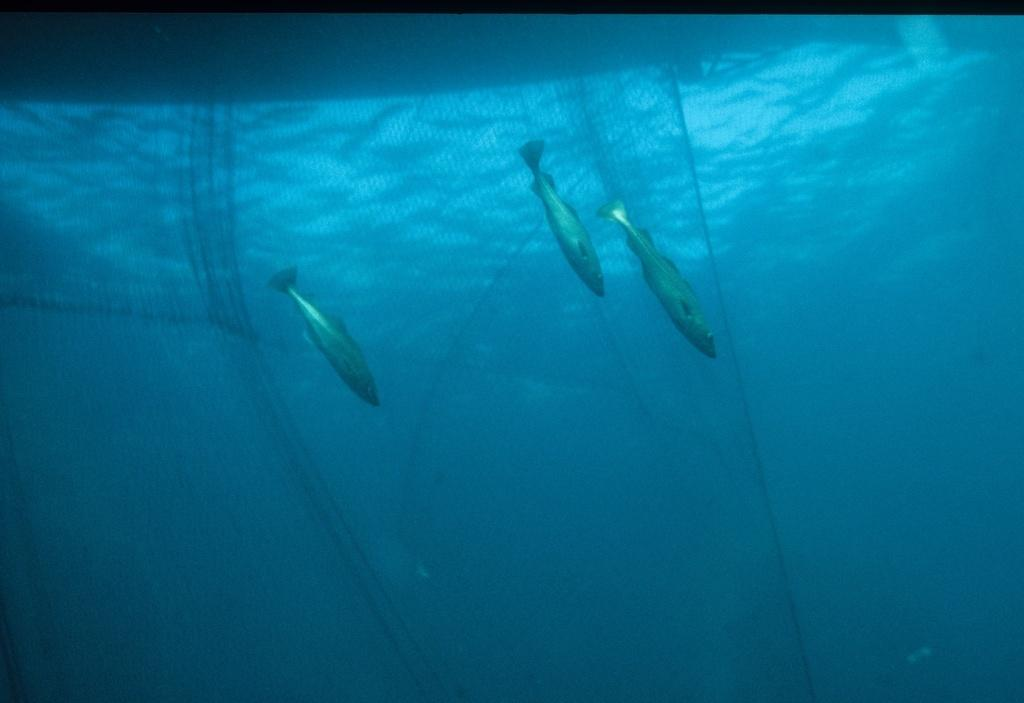What type of animals can be seen in the image? There are fishes in the image. What object is present in the image that might be used for catching or collecting the fishes? There is a net in the image. Where are the fishes and net located in the image? The fishes and net are in the water. What type of maid can be seen cleaning the steam in the image? There is no maid or steam present in the image; it features fishes and a net in the water. 